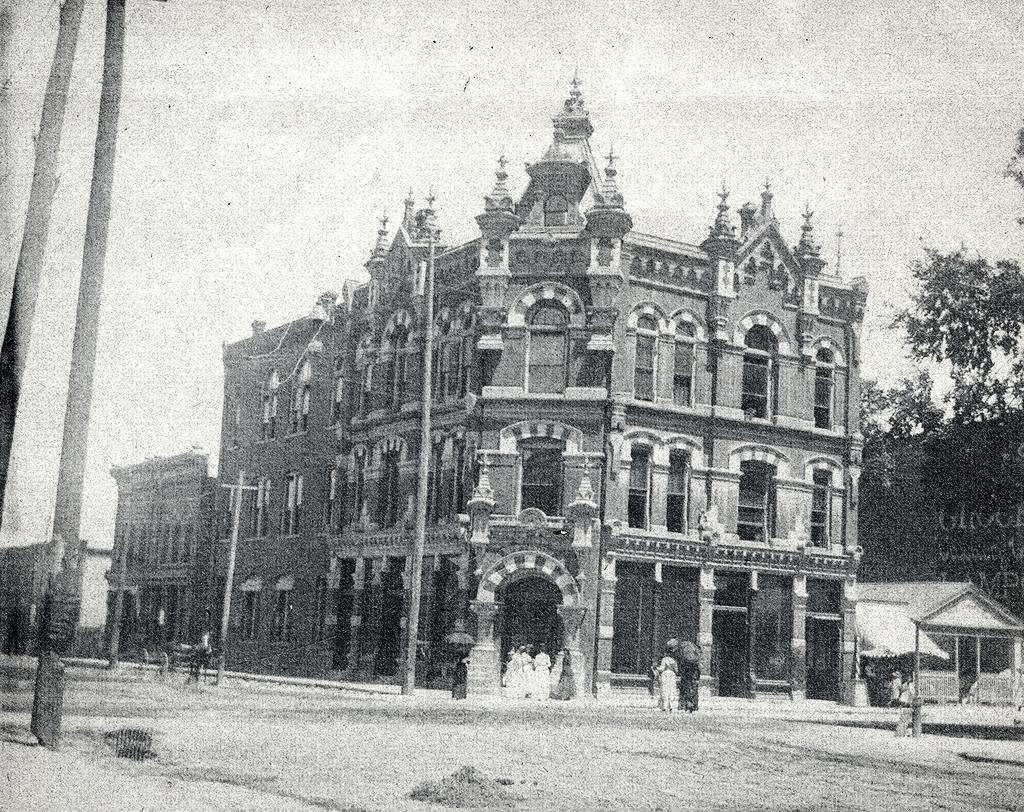What structures can be seen in the image? There are poles in the image. What else can be seen in the distance? People, buildings, and trees are visible in the distance. What is visible in the background of the image? The sky is visible in the background of the image. How do the dinosaurs affect the acoustics in the image? There are no dinosaurs present in the image, so their impact on the acoustics cannot be determined. 